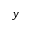Convert formula to latex. <formula><loc_0><loc_0><loc_500><loc_500>y</formula> 